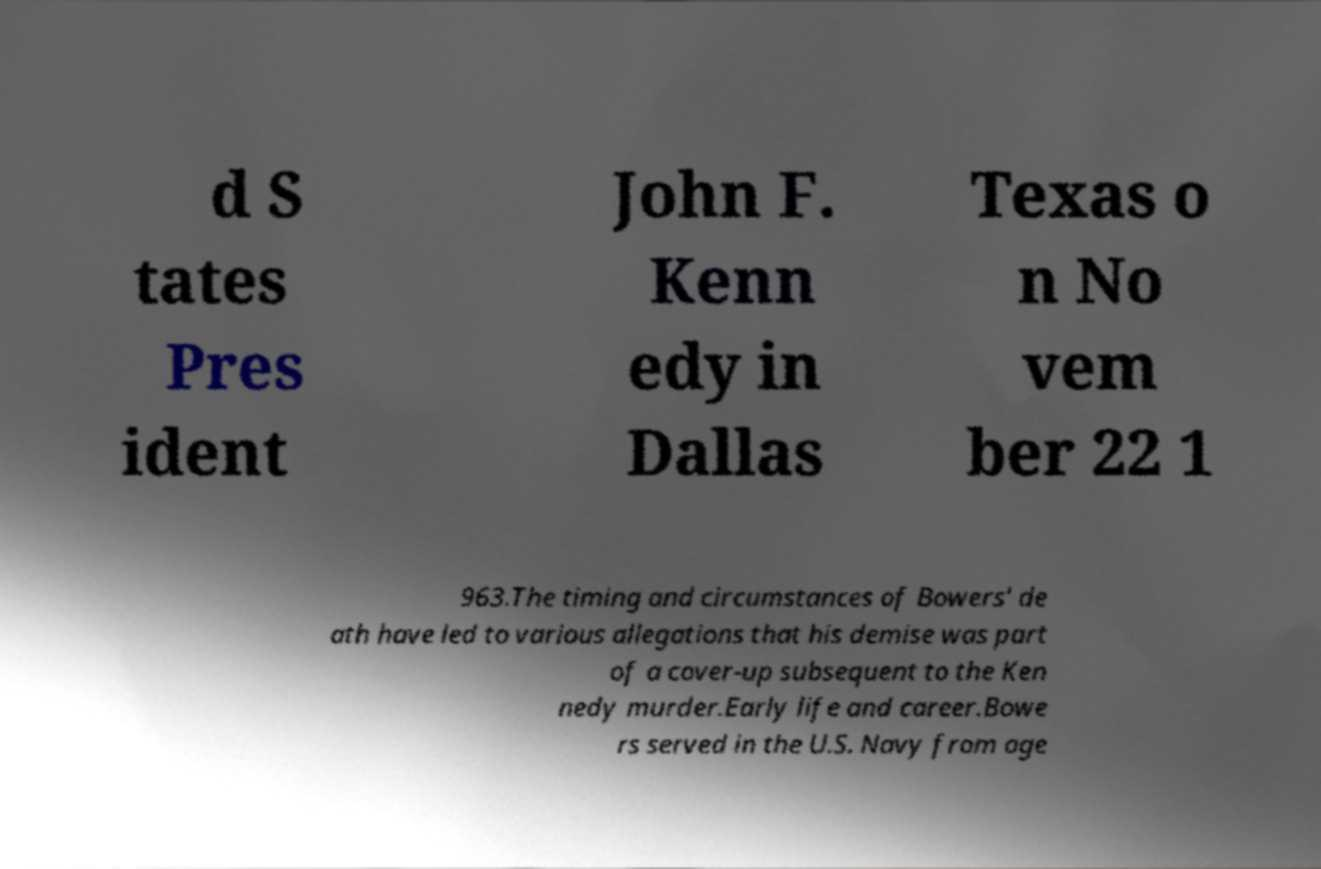Can you read and provide the text displayed in the image?This photo seems to have some interesting text. Can you extract and type it out for me? d S tates Pres ident John F. Kenn edy in Dallas Texas o n No vem ber 22 1 963.The timing and circumstances of Bowers' de ath have led to various allegations that his demise was part of a cover-up subsequent to the Ken nedy murder.Early life and career.Bowe rs served in the U.S. Navy from age 